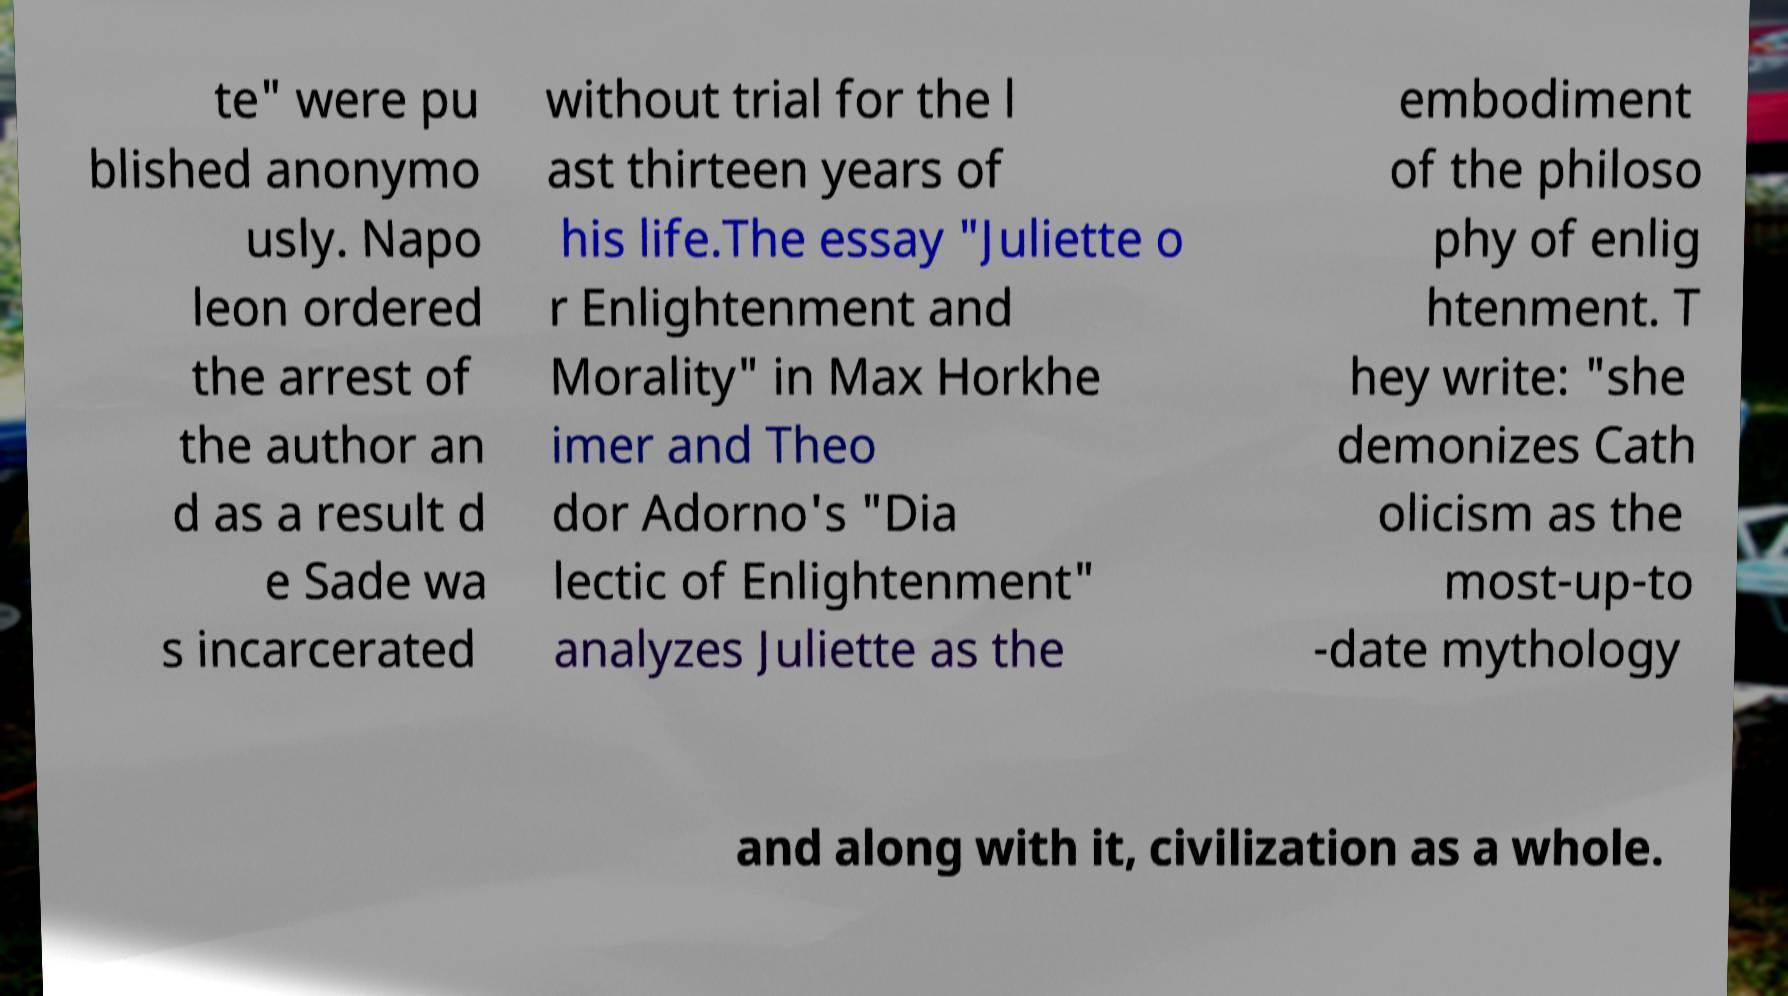I need the written content from this picture converted into text. Can you do that? te" were pu blished anonymo usly. Napo leon ordered the arrest of the author an d as a result d e Sade wa s incarcerated without trial for the l ast thirteen years of his life.The essay "Juliette o r Enlightenment and Morality" in Max Horkhe imer and Theo dor Adorno's "Dia lectic of Enlightenment" analyzes Juliette as the embodiment of the philoso phy of enlig htenment. T hey write: "she demonizes Cath olicism as the most-up-to -date mythology and along with it, civilization as a whole. 